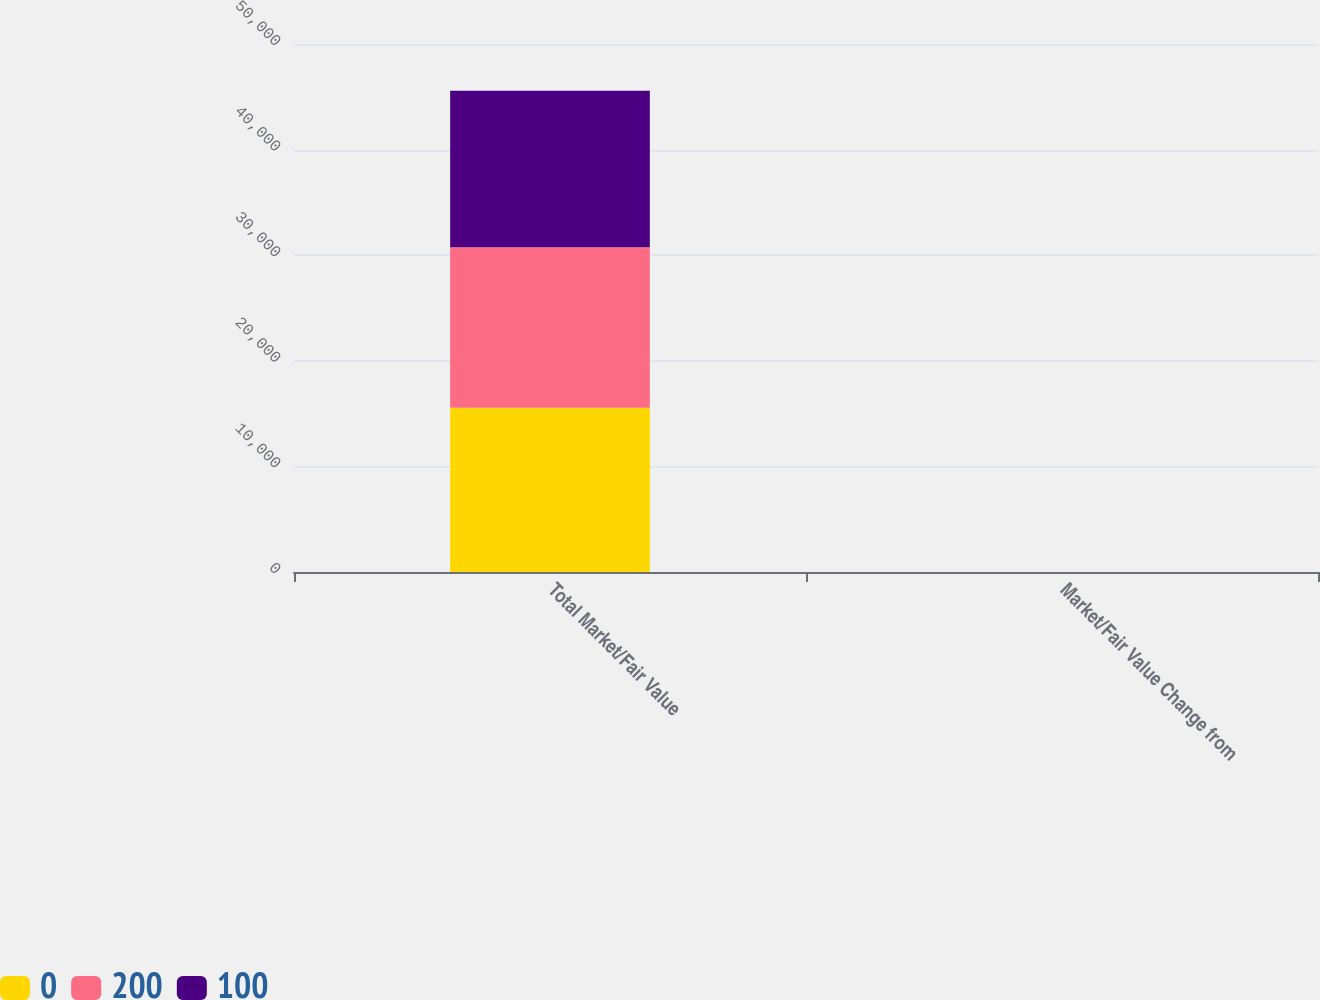<chart> <loc_0><loc_0><loc_500><loc_500><stacked_bar_chart><ecel><fcel>Total Market/Fair Value<fcel>Market/Fair Value Change from<nl><fcel>0<fcel>15563.2<fcel>5.1<nl><fcel>200<fcel>15194.2<fcel>2.6<nl><fcel>100<fcel>14808.5<fcel>0<nl></chart> 